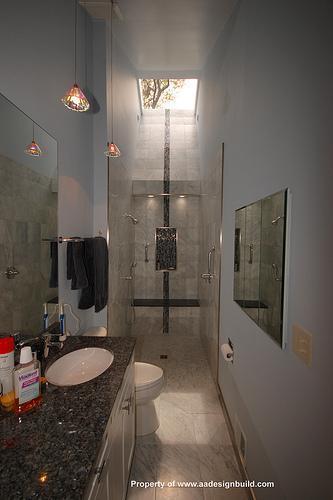How many toilets are in the room?
Give a very brief answer. 1. 